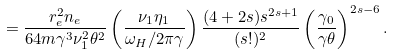Convert formula to latex. <formula><loc_0><loc_0><loc_500><loc_500>= \frac { r _ { e } ^ { 2 } n _ { e } } { 6 4 m \gamma ^ { 3 } \nu _ { 1 } ^ { 2 } \theta ^ { 2 } } \left ( \frac { \nu _ { 1 } \eta _ { 1 } } { \omega _ { H } / 2 \pi \gamma } \right ) \frac { ( 4 + 2 s ) s ^ { 2 s + 1 } } { ( s ! ) ^ { 2 } } \left ( \frac { \gamma _ { 0 } } { \gamma \theta } \right ) ^ { 2 s - 6 } .</formula> 